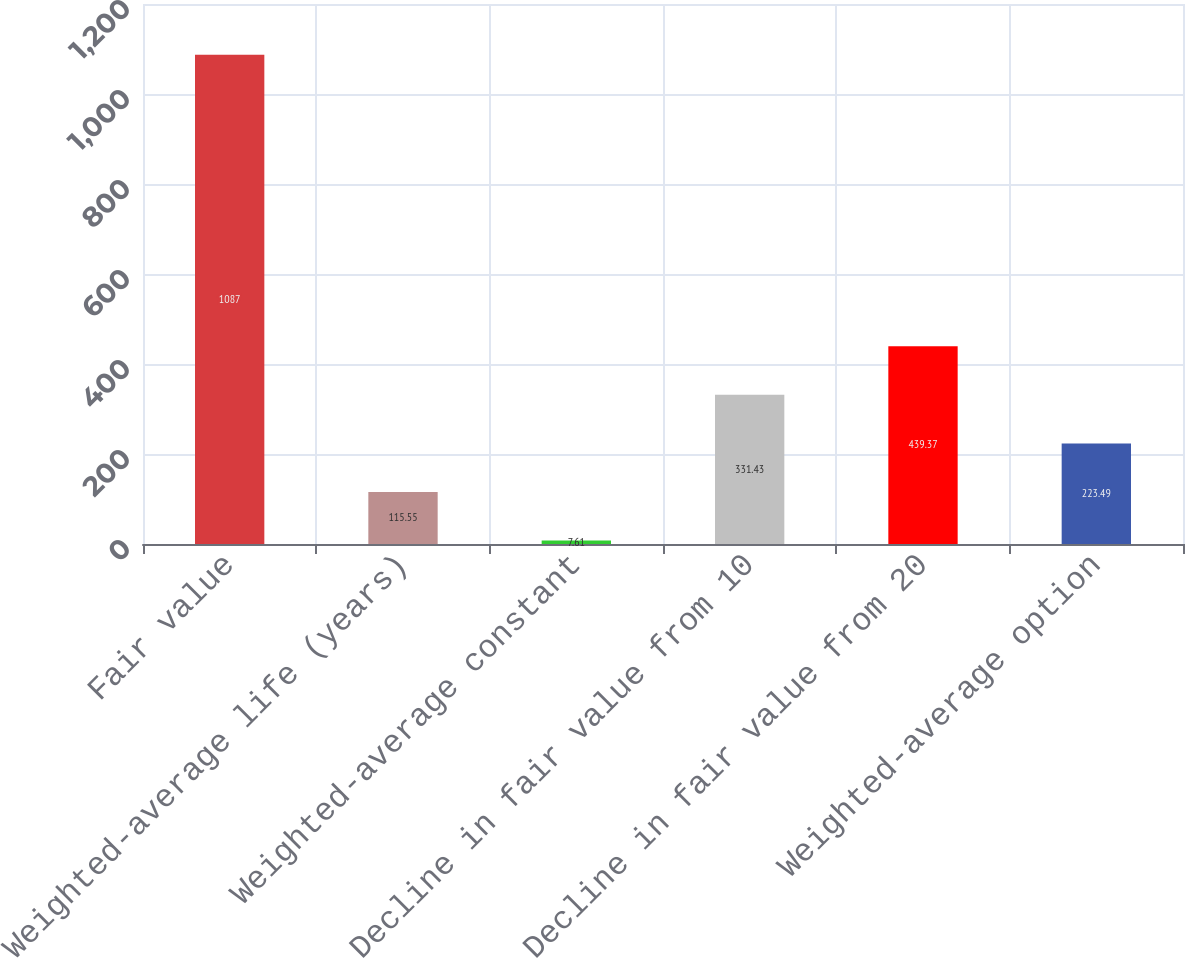<chart> <loc_0><loc_0><loc_500><loc_500><bar_chart><fcel>Fair value<fcel>Weighted-average life (years)<fcel>Weighted-average constant<fcel>Decline in fair value from 10<fcel>Decline in fair value from 20<fcel>Weighted-average option<nl><fcel>1087<fcel>115.55<fcel>7.61<fcel>331.43<fcel>439.37<fcel>223.49<nl></chart> 